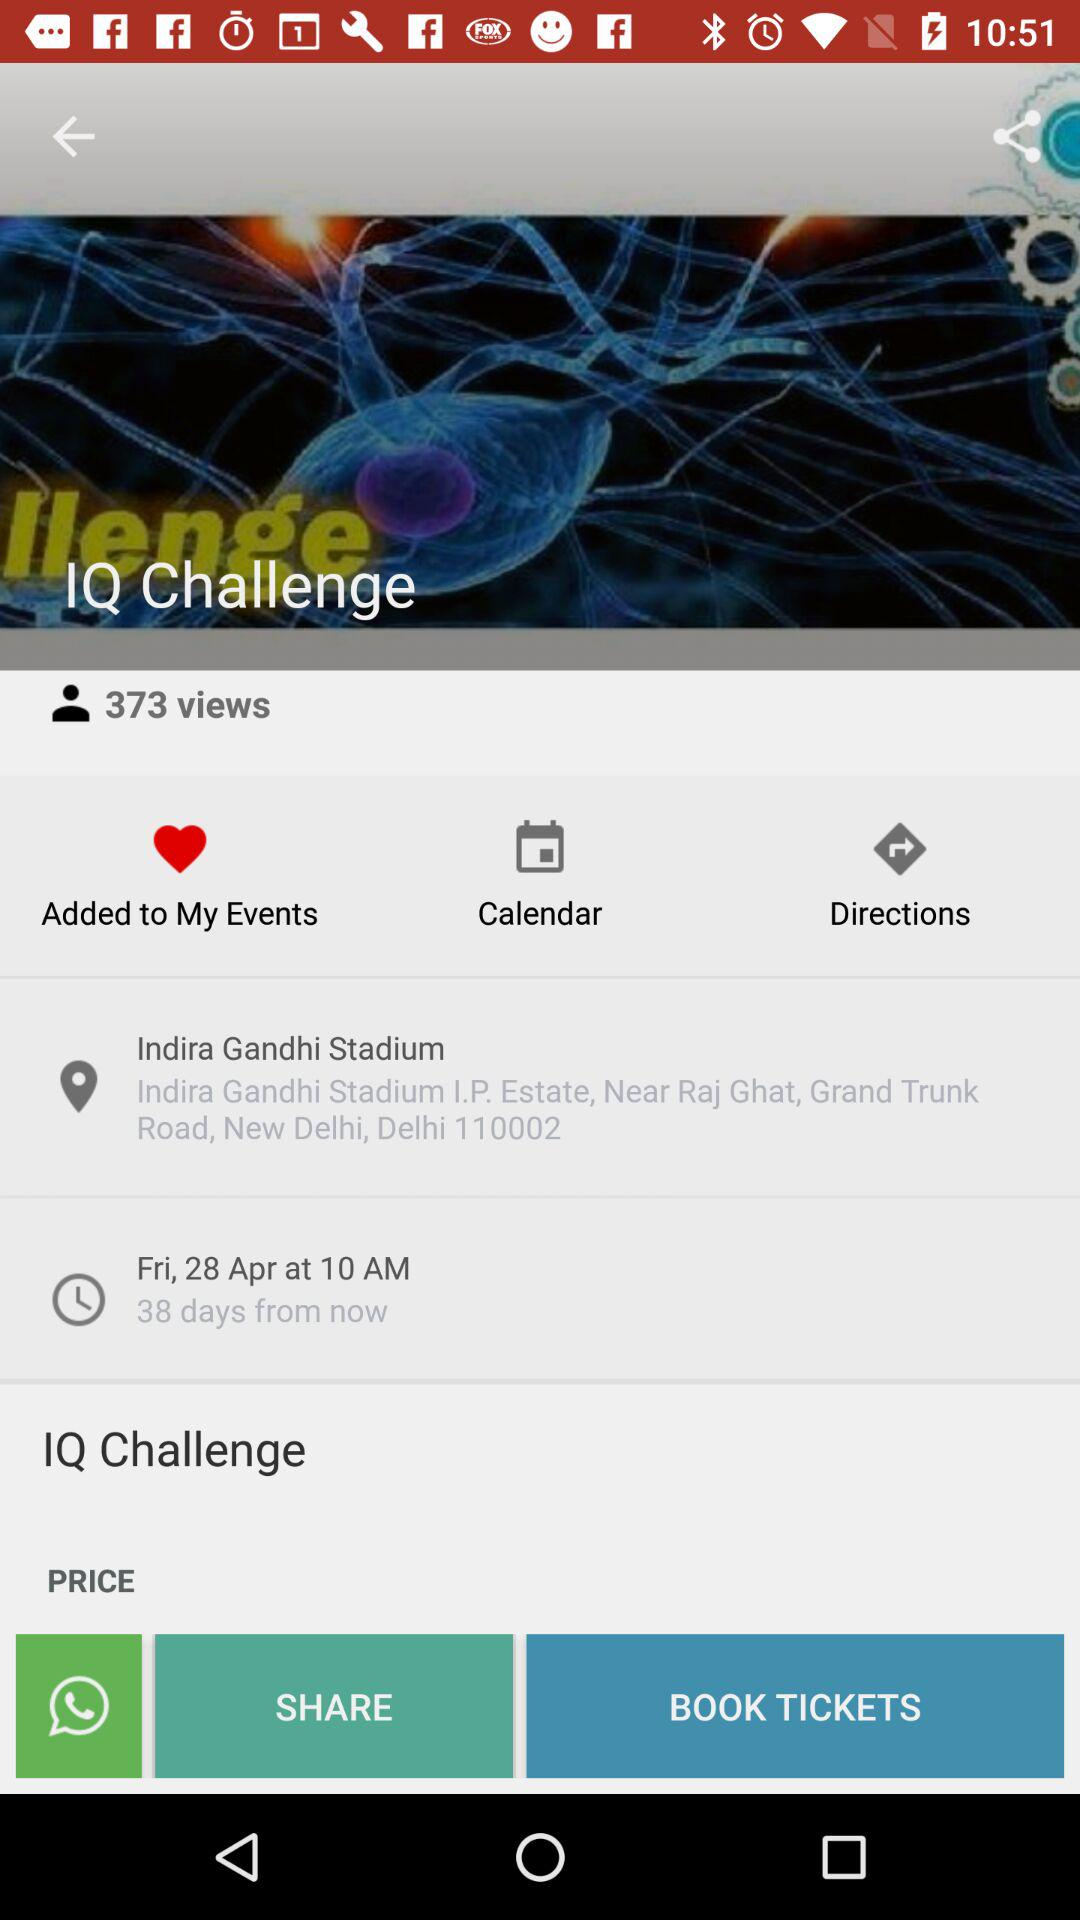What is the mentioned location? The location is Indira Gandhi Stadium I.P. Estate, near Raj Ghat, Grand Trunk Road, New Delhi, Delhi 110002. 